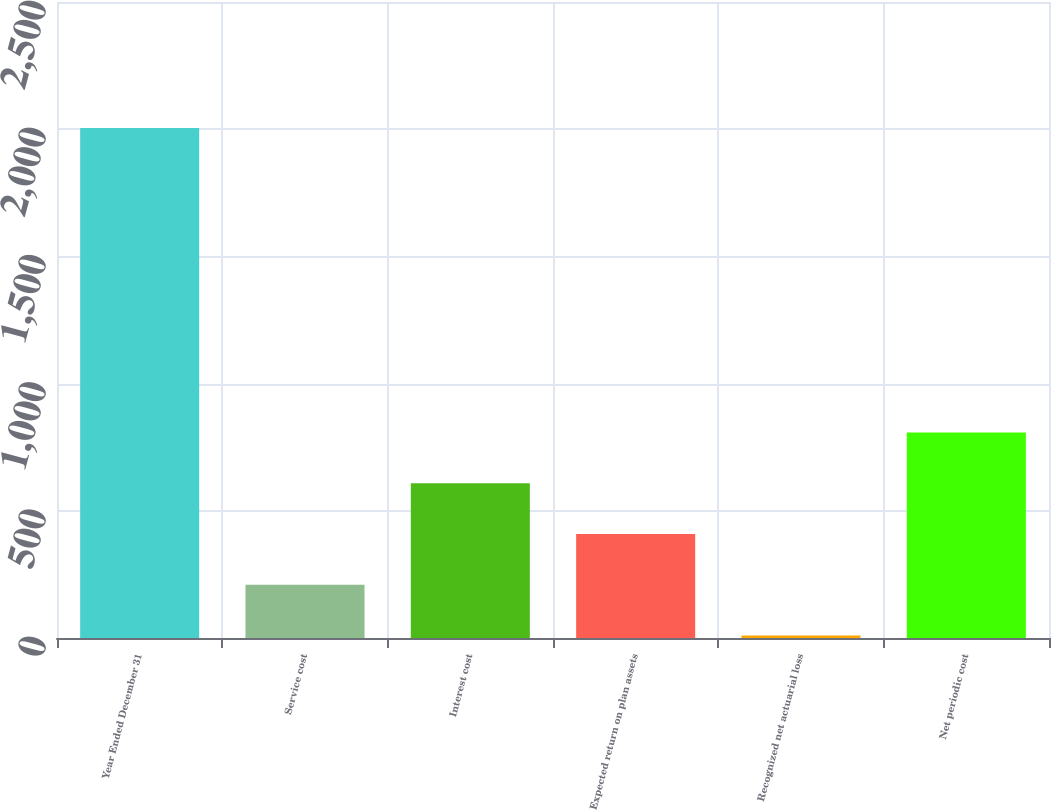<chart> <loc_0><loc_0><loc_500><loc_500><bar_chart><fcel>Year Ended December 31<fcel>Service cost<fcel>Interest cost<fcel>Expected return on plan assets<fcel>Recognized net actuarial loss<fcel>Net periodic cost<nl><fcel>2005<fcel>209.5<fcel>608.5<fcel>409<fcel>10<fcel>808<nl></chart> 